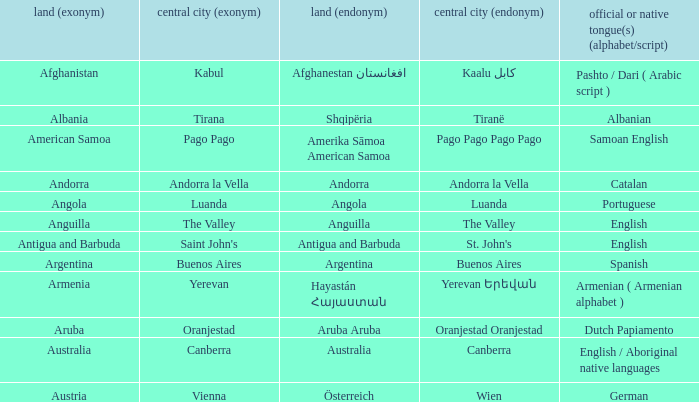What is the local name given to the capital of Anguilla? The Valley. 